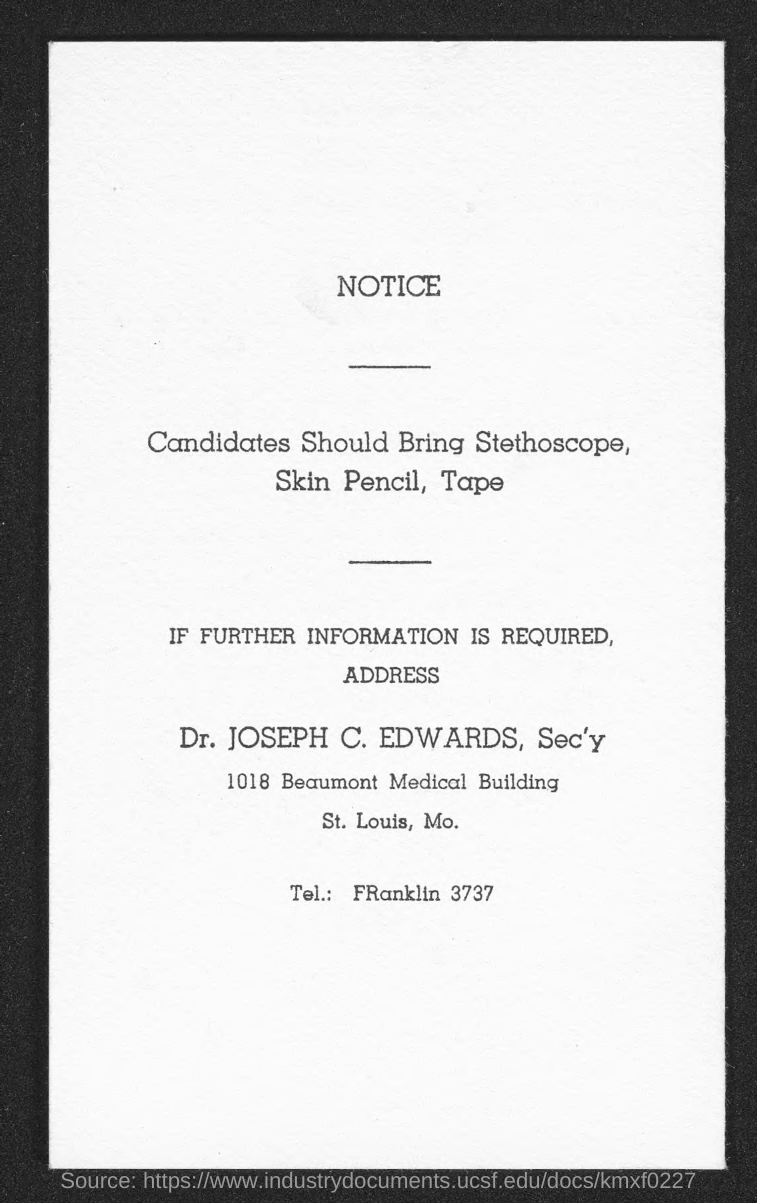Whom to contact for further information?
Ensure brevity in your answer.  Dr. Joseph C. Edwards. What is the Tel. given?
Ensure brevity in your answer.  FRanklin 3737. What type of documentation is this?
Your answer should be very brief. Notice. What should Candidates bring?
Provide a succinct answer. Stethoscope, Skin Pencil, Tape. 